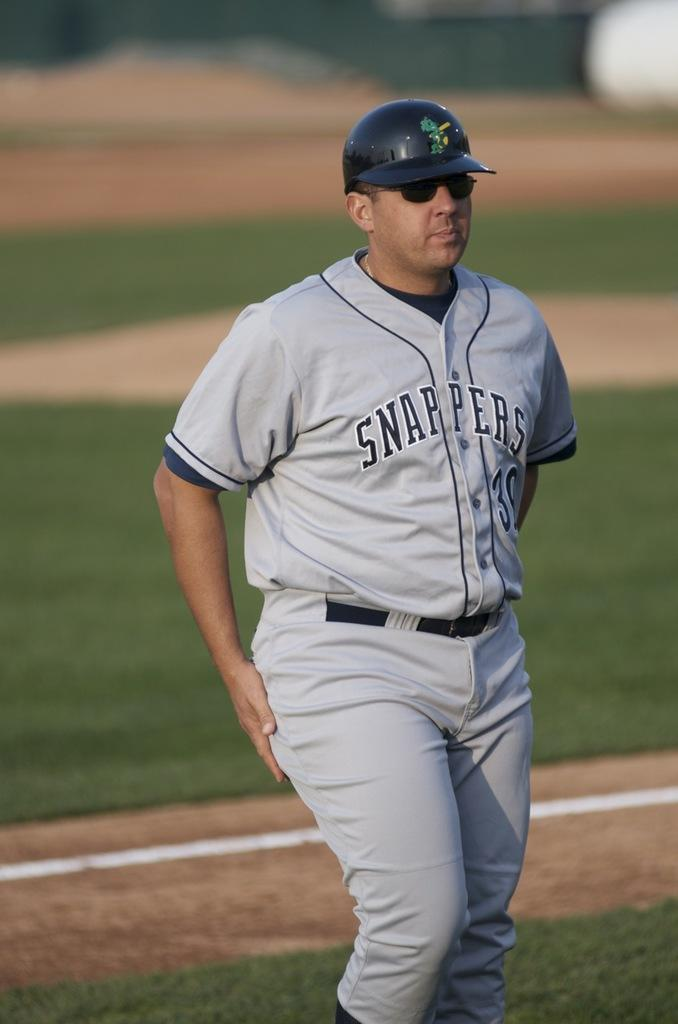What is the main subject of the image? There is a person in the image. What is the person wearing on their head? The person is wearing a helmet. What type of surface is the person standing on? The person is standing on the surface of the grass. Where is the drum located in the image? There is no drum present in the image. What is the person doing with their chin in the image? The person is not doing anything with their chin in the image; they are simply standing on the grass with a helmet on their head. 